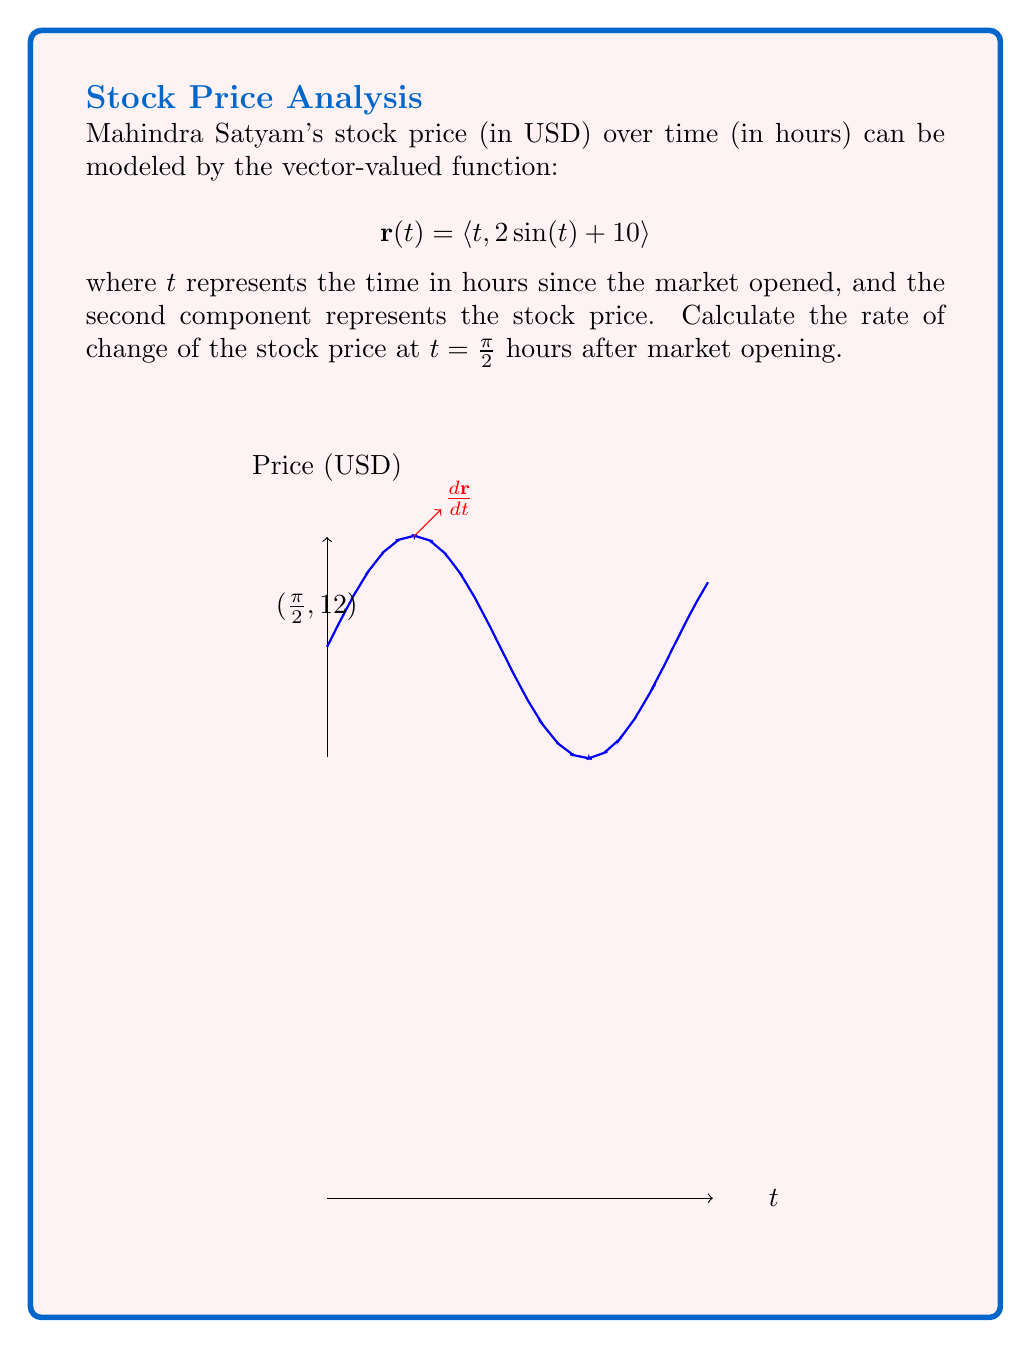Solve this math problem. To find the rate of change of the stock price, we need to calculate the derivative of the vector-valued function and evaluate it at $t = \frac{\pi}{2}$.

1) The vector-valued function is:
   $$\mathbf{r}(t) = \langle t, 2\sin(t) + 10 \rangle$$

2) To find the derivative, we differentiate each component:
   $$\frac{d\mathbf{r}}{dt} = \langle \frac{d}{dt}(t), \frac{d}{dt}(2\sin(t) + 10) \rangle$$

3) Simplifying:
   $$\frac{d\mathbf{r}}{dt} = \langle 1, 2\cos(t) \rangle$$

4) The rate of change of the stock price is given by the second component of this derivative.

5) Evaluating at $t = \frac{\pi}{2}$:
   $$\frac{d\mathbf{r}}{dt}\bigg|_{t=\frac{\pi}{2}} = \langle 1, 2\cos(\frac{\pi}{2}) \rangle$$

6) We know that $\cos(\frac{\pi}{2}) = 0$, so:
   $$\frac{d\mathbf{r}}{dt}\bigg|_{t=\frac{\pi}{2}} = \langle 1, 0 \rangle$$

7) The second component, 0, represents the rate of change of the stock price at $t = \frac{\pi}{2}$.
Answer: $0$ USD/hour 